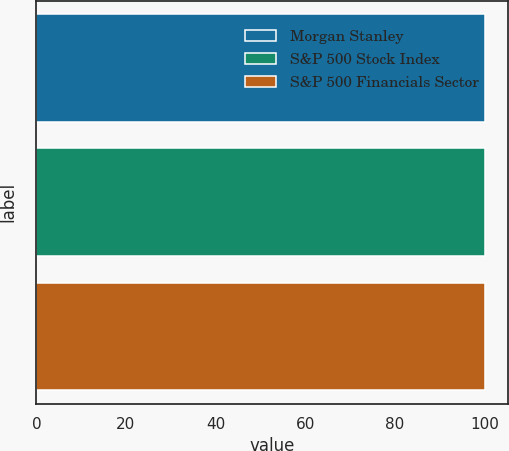Convert chart. <chart><loc_0><loc_0><loc_500><loc_500><bar_chart><fcel>Morgan Stanley<fcel>S&P 500 Stock Index<fcel>S&P 500 Financials Sector<nl><fcel>100<fcel>100.1<fcel>100.2<nl></chart> 